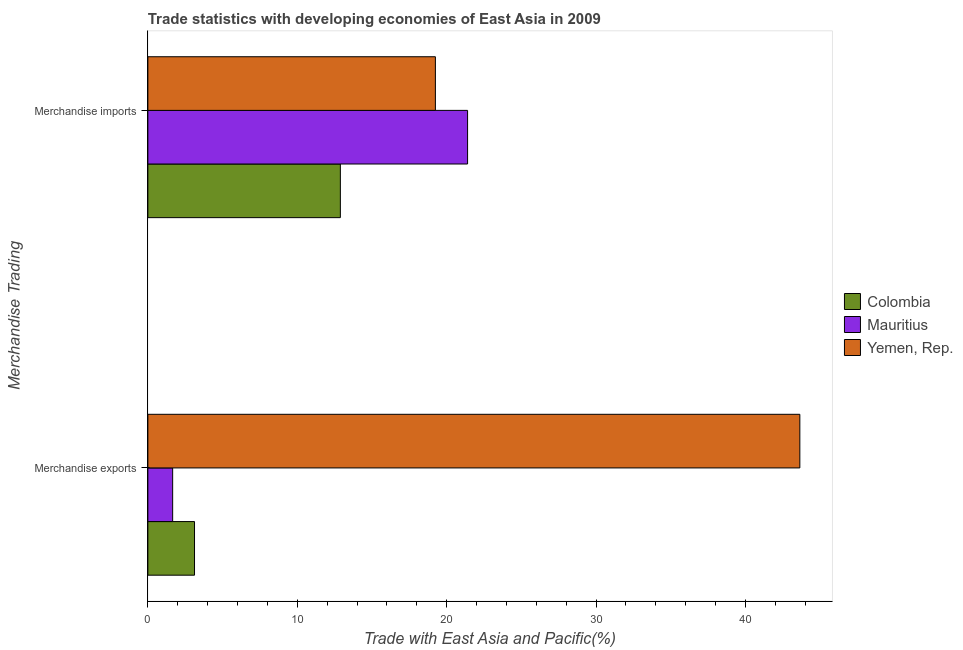Are the number of bars per tick equal to the number of legend labels?
Your answer should be very brief. Yes. Are the number of bars on each tick of the Y-axis equal?
Your answer should be very brief. Yes. What is the merchandise imports in Mauritius?
Your answer should be very brief. 21.4. Across all countries, what is the maximum merchandise exports?
Ensure brevity in your answer.  43.65. Across all countries, what is the minimum merchandise exports?
Provide a short and direct response. 1.66. In which country was the merchandise imports maximum?
Provide a succinct answer. Mauritius. In which country was the merchandise exports minimum?
Provide a short and direct response. Mauritius. What is the total merchandise exports in the graph?
Provide a short and direct response. 48.43. What is the difference between the merchandise exports in Colombia and that in Yemen, Rep.?
Provide a succinct answer. -40.52. What is the difference between the merchandise exports in Mauritius and the merchandise imports in Yemen, Rep.?
Keep it short and to the point. -17.59. What is the average merchandise exports per country?
Your answer should be compact. 16.14. What is the difference between the merchandise imports and merchandise exports in Colombia?
Your response must be concise. 9.76. In how many countries, is the merchandise exports greater than 38 %?
Your response must be concise. 1. What is the ratio of the merchandise exports in Colombia to that in Yemen, Rep.?
Your answer should be compact. 0.07. What does the 2nd bar from the bottom in Merchandise imports represents?
Give a very brief answer. Mauritius. What is the difference between two consecutive major ticks on the X-axis?
Provide a succinct answer. 10. Where does the legend appear in the graph?
Make the answer very short. Center right. How many legend labels are there?
Provide a succinct answer. 3. What is the title of the graph?
Your response must be concise. Trade statistics with developing economies of East Asia in 2009. What is the label or title of the X-axis?
Your answer should be compact. Trade with East Asia and Pacific(%). What is the label or title of the Y-axis?
Keep it short and to the point. Merchandise Trading. What is the Trade with East Asia and Pacific(%) in Colombia in Merchandise exports?
Give a very brief answer. 3.12. What is the Trade with East Asia and Pacific(%) of Mauritius in Merchandise exports?
Make the answer very short. 1.66. What is the Trade with East Asia and Pacific(%) of Yemen, Rep. in Merchandise exports?
Your response must be concise. 43.65. What is the Trade with East Asia and Pacific(%) of Colombia in Merchandise imports?
Offer a very short reply. 12.89. What is the Trade with East Asia and Pacific(%) in Mauritius in Merchandise imports?
Keep it short and to the point. 21.4. What is the Trade with East Asia and Pacific(%) in Yemen, Rep. in Merchandise imports?
Make the answer very short. 19.25. Across all Merchandise Trading, what is the maximum Trade with East Asia and Pacific(%) in Colombia?
Your response must be concise. 12.89. Across all Merchandise Trading, what is the maximum Trade with East Asia and Pacific(%) of Mauritius?
Keep it short and to the point. 21.4. Across all Merchandise Trading, what is the maximum Trade with East Asia and Pacific(%) of Yemen, Rep.?
Your answer should be compact. 43.65. Across all Merchandise Trading, what is the minimum Trade with East Asia and Pacific(%) of Colombia?
Your response must be concise. 3.12. Across all Merchandise Trading, what is the minimum Trade with East Asia and Pacific(%) of Mauritius?
Offer a terse response. 1.66. Across all Merchandise Trading, what is the minimum Trade with East Asia and Pacific(%) of Yemen, Rep.?
Your response must be concise. 19.25. What is the total Trade with East Asia and Pacific(%) of Colombia in the graph?
Provide a short and direct response. 16.01. What is the total Trade with East Asia and Pacific(%) in Mauritius in the graph?
Give a very brief answer. 23.06. What is the total Trade with East Asia and Pacific(%) of Yemen, Rep. in the graph?
Give a very brief answer. 62.89. What is the difference between the Trade with East Asia and Pacific(%) in Colombia in Merchandise exports and that in Merchandise imports?
Keep it short and to the point. -9.76. What is the difference between the Trade with East Asia and Pacific(%) in Mauritius in Merchandise exports and that in Merchandise imports?
Offer a very short reply. -19.74. What is the difference between the Trade with East Asia and Pacific(%) of Yemen, Rep. in Merchandise exports and that in Merchandise imports?
Ensure brevity in your answer.  24.4. What is the difference between the Trade with East Asia and Pacific(%) of Colombia in Merchandise exports and the Trade with East Asia and Pacific(%) of Mauritius in Merchandise imports?
Provide a short and direct response. -18.28. What is the difference between the Trade with East Asia and Pacific(%) in Colombia in Merchandise exports and the Trade with East Asia and Pacific(%) in Yemen, Rep. in Merchandise imports?
Ensure brevity in your answer.  -16.12. What is the difference between the Trade with East Asia and Pacific(%) of Mauritius in Merchandise exports and the Trade with East Asia and Pacific(%) of Yemen, Rep. in Merchandise imports?
Your response must be concise. -17.59. What is the average Trade with East Asia and Pacific(%) of Colombia per Merchandise Trading?
Provide a succinct answer. 8. What is the average Trade with East Asia and Pacific(%) in Mauritius per Merchandise Trading?
Provide a succinct answer. 11.53. What is the average Trade with East Asia and Pacific(%) of Yemen, Rep. per Merchandise Trading?
Keep it short and to the point. 31.45. What is the difference between the Trade with East Asia and Pacific(%) of Colombia and Trade with East Asia and Pacific(%) of Mauritius in Merchandise exports?
Provide a short and direct response. 1.46. What is the difference between the Trade with East Asia and Pacific(%) of Colombia and Trade with East Asia and Pacific(%) of Yemen, Rep. in Merchandise exports?
Make the answer very short. -40.52. What is the difference between the Trade with East Asia and Pacific(%) in Mauritius and Trade with East Asia and Pacific(%) in Yemen, Rep. in Merchandise exports?
Your answer should be compact. -41.99. What is the difference between the Trade with East Asia and Pacific(%) in Colombia and Trade with East Asia and Pacific(%) in Mauritius in Merchandise imports?
Offer a terse response. -8.52. What is the difference between the Trade with East Asia and Pacific(%) in Colombia and Trade with East Asia and Pacific(%) in Yemen, Rep. in Merchandise imports?
Provide a short and direct response. -6.36. What is the difference between the Trade with East Asia and Pacific(%) in Mauritius and Trade with East Asia and Pacific(%) in Yemen, Rep. in Merchandise imports?
Your answer should be compact. 2.15. What is the ratio of the Trade with East Asia and Pacific(%) in Colombia in Merchandise exports to that in Merchandise imports?
Offer a terse response. 0.24. What is the ratio of the Trade with East Asia and Pacific(%) in Mauritius in Merchandise exports to that in Merchandise imports?
Your answer should be compact. 0.08. What is the ratio of the Trade with East Asia and Pacific(%) of Yemen, Rep. in Merchandise exports to that in Merchandise imports?
Make the answer very short. 2.27. What is the difference between the highest and the second highest Trade with East Asia and Pacific(%) in Colombia?
Keep it short and to the point. 9.76. What is the difference between the highest and the second highest Trade with East Asia and Pacific(%) in Mauritius?
Offer a very short reply. 19.74. What is the difference between the highest and the second highest Trade with East Asia and Pacific(%) of Yemen, Rep.?
Provide a short and direct response. 24.4. What is the difference between the highest and the lowest Trade with East Asia and Pacific(%) of Colombia?
Your answer should be very brief. 9.76. What is the difference between the highest and the lowest Trade with East Asia and Pacific(%) of Mauritius?
Provide a succinct answer. 19.74. What is the difference between the highest and the lowest Trade with East Asia and Pacific(%) in Yemen, Rep.?
Make the answer very short. 24.4. 